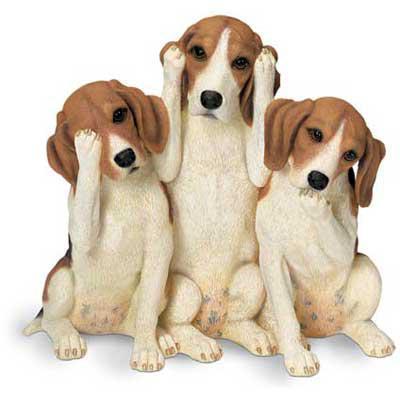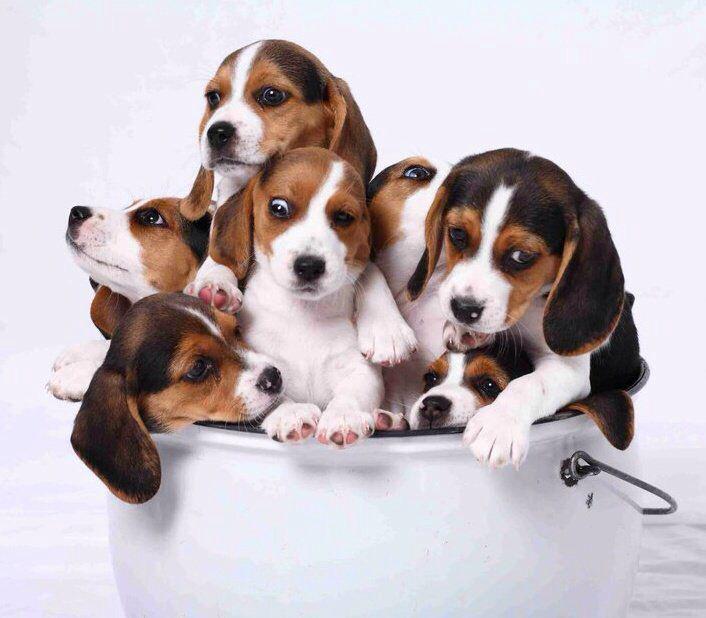The first image is the image on the left, the second image is the image on the right. Analyze the images presented: Is the assertion "There are three dogs in each of the images." valid? Answer yes or no. No. 